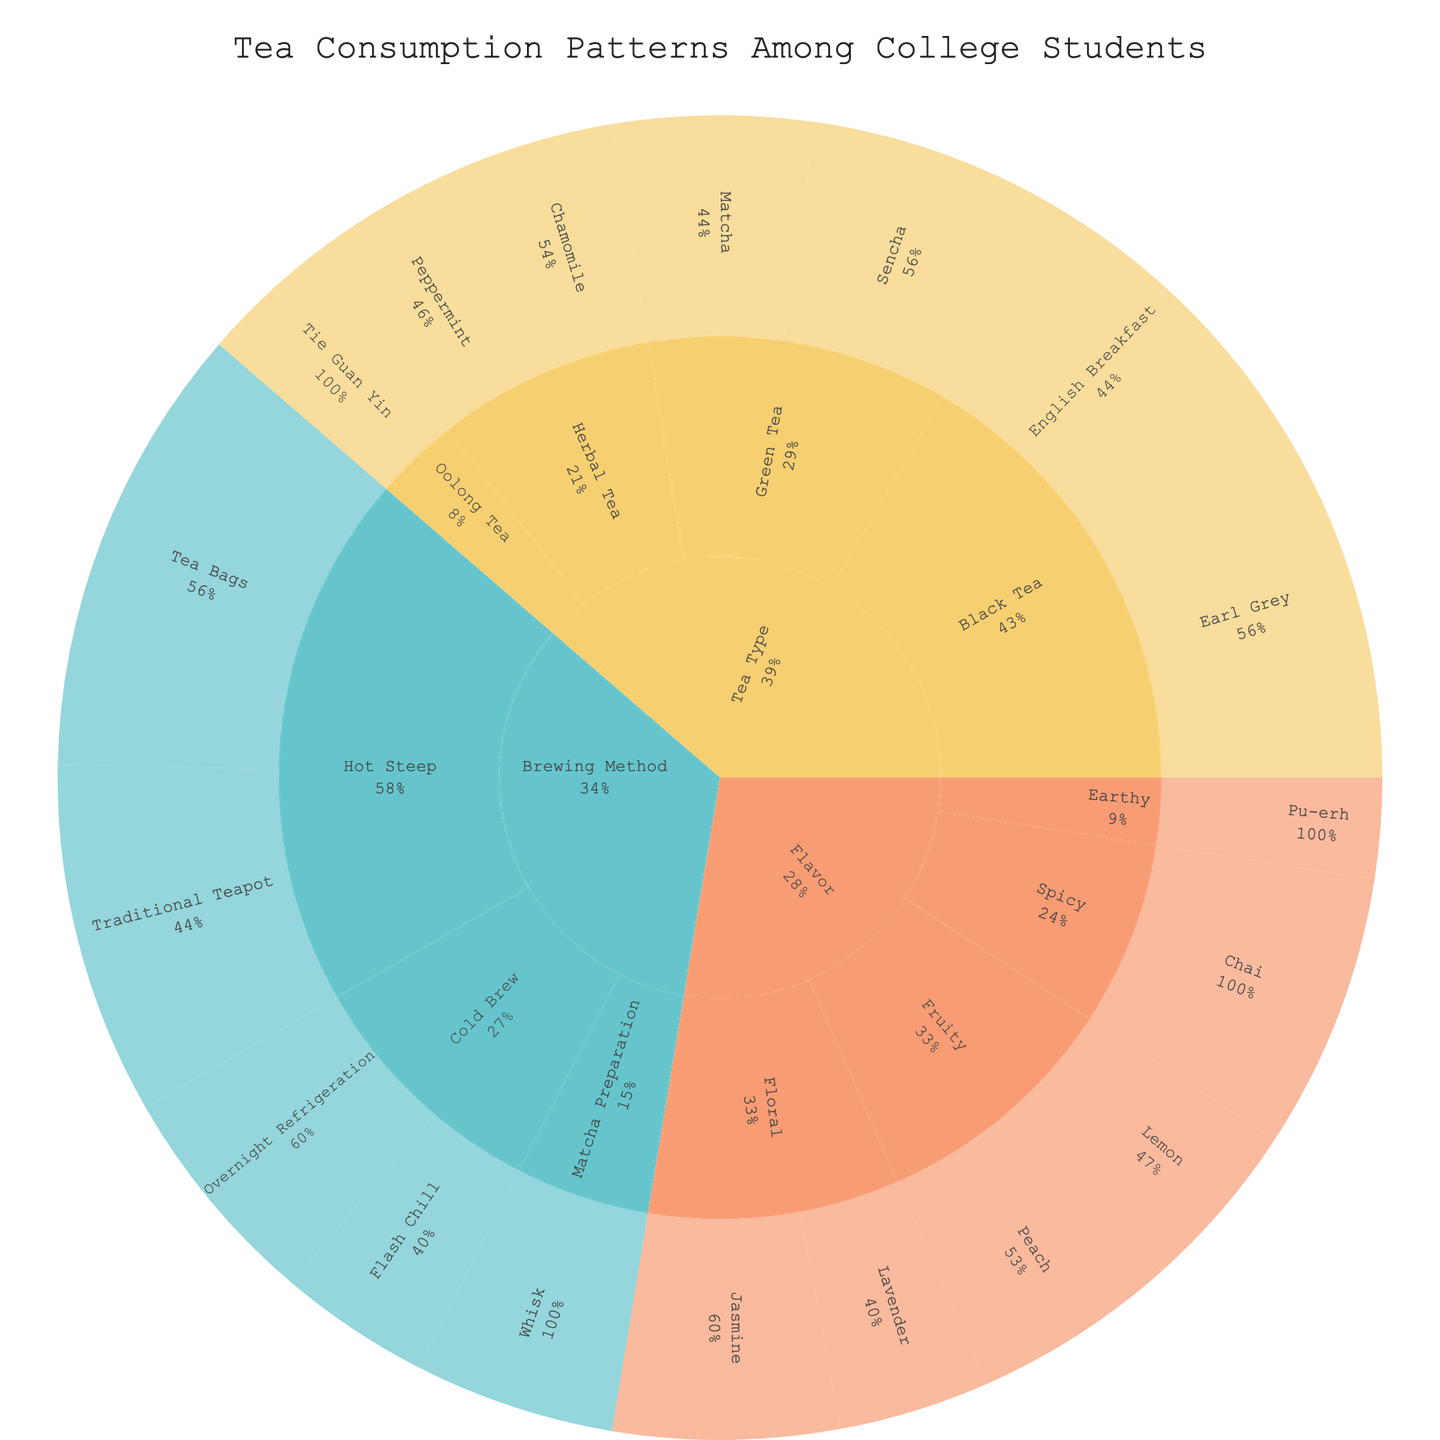What is the title of the figure? The title is located at the top of the plot and describes the overall subject of the figure.
Answer: Tea Consumption Patterns Among College Students How many subcategories are there under the "Tea Type" category? Count the distinct subcategories branching out from the "Tea Type" category.
Answer: Four: Black Tea, Green Tea, Herbal Tea, Oolong Tea Which item under the "Flavor" category has the highest value? Look at the branches under the "Flavor" category and compare their values.
Answer: Chai How does the consumption of "Earl Grey" compare to "English Breakfast"? Find both items under the "Black Tea" subcategory and compare their values.
Answer: Earl Grey (15) is higher than English Breakfast (12) What is the total consumption of items under the "Hot Steep" brewing method? Sum the values of all items under the "Hot Steep" subcategory. 14 (Traditional Teapot) + 18 (Tea Bags) = 32
Answer: 32 What percentage of the "Herbal Tea" subcategory does "Chamomile" constitute? Divide the value of "Chamomile" by the total value of the "Herbal Tea" subcategory and multiply by 100. 7/13 (total of Chamomile and Peppermint) * 100 = ~53.8%
Answer: ~53.8% Which brewing method has the least total consumption? Sum values for each brewing method and compare the totals. Cold Brew: 9+6=15, Matcha Preparation: 8, Hot Steep: 32
Answer: Matcha Preparation What is the range of values for items in the "Flavor" category? Identify the maximum and minimum values among items in the "Flavor" category and find the difference. Max: 11 (Chai), Min: 4 (Pu-erh), so the range is 11 - 4 = 7
Answer: 7 Which has a greater total value: "Black Tea" or "Green Tea"? Sum the values of items under "Black Tea" and "Green Tea", then compare the sums. Black Tea: 15 + 12 = 27, Green Tea: 10 + 8 = 18
Answer: Black Tea Of all the items displayed, which has the smallest value? Look at the values for all items and identify the smallest one.
Answer: Pu-erh 